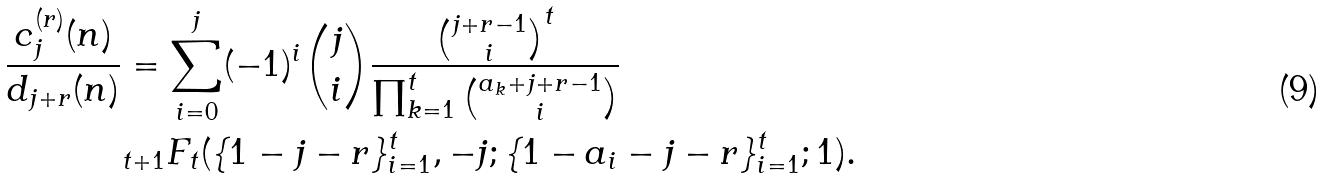Convert formula to latex. <formula><loc_0><loc_0><loc_500><loc_500>\frac { c _ { j } ^ { ( r ) } ( n ) } { d _ { j + r } ( n ) } & = \sum _ { i = 0 } ^ { j } ( - 1 ) ^ { i } { j \choose i } \frac { { j + r - 1 \choose i } ^ { t } } { \prod _ { k = 1 } ^ { t } { a _ { k } + j + r - 1 \choose i } } \\ & _ { t + 1 } F _ { t } ( \{ 1 - j - r \} _ { i = 1 } ^ { t } , - j ; \{ 1 - a _ { i } - j - r \} ^ { t } _ { i = 1 } ; 1 ) .</formula> 